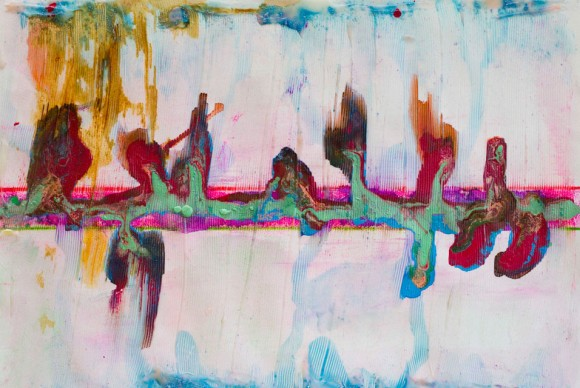What do you see happening in this image? The image you've shared is a captivating piece of abstract art. It's a symphony of colors and shapes, blending together to create a unique visual experience. The colors are predominantly pastel, lending a soft and soothing aura to the piece, but there are also darker shades interspersed throughout, adding depth and contrast.

The art style is distinctly abstract, characterized by the use of non-representational forms and shapes. This style is often associated with the modern art genre, which seeks to break away from traditional artistic norms and conventions.

The painting appears to be created using a mix of different mediums, possibly including paint and collage. This combination of mediums adds a rich texture to the piece, making it even more visually intriguing.

The composition of the painting is primarily horizontal, but there are also vertical elements that disrupt this pattern and add dynamism to the piece. The symmetry of the painting is not perfect, with some asymmetrical elements that further enhance its abstract nature.

Overall, this painting is a beautiful representation of the abstract art style, showcasing the artist's ability to play with colors, shapes, and mediums to create a visually stunning piece. 